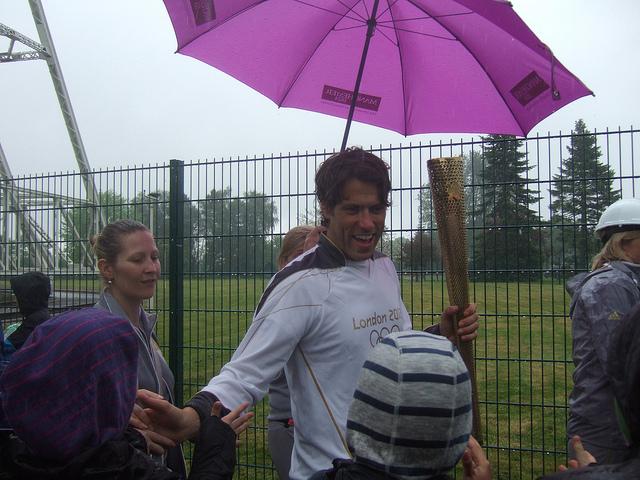In what country is this scene likely in?
Keep it brief. England. Is there a man with glasses?
Short answer required. No. Is the hat striped?
Answer briefly. Yes. What color is the umbrella?
Write a very short answer. Purple. 